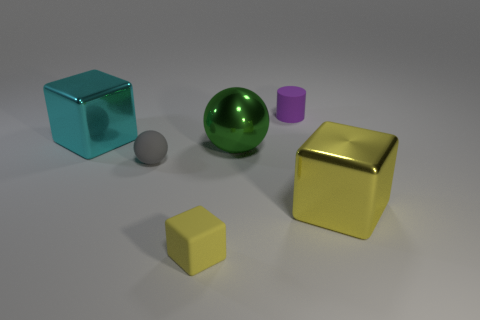What number of things are blocks on the right side of the small rubber block or metallic cubes?
Provide a short and direct response. 2. Is the color of the cube that is in front of the large yellow metal thing the same as the big thing that is in front of the small gray matte ball?
Provide a succinct answer. Yes. The cylinder has what size?
Ensure brevity in your answer.  Small. How many big objects are either green shiny things or blue rubber cubes?
Offer a very short reply. 1. What color is the cube that is the same size as the purple thing?
Keep it short and to the point. Yellow. How many other objects are the same shape as the tiny purple matte thing?
Your answer should be compact. 0. Are there any large brown cylinders made of the same material as the big sphere?
Provide a short and direct response. No. Is the large cube in front of the small gray thing made of the same material as the purple thing behind the tiny gray rubber object?
Keep it short and to the point. No. What number of small cylinders are there?
Your answer should be compact. 1. There is a yellow object that is on the right side of the rubber block; what shape is it?
Your answer should be very brief. Cube. 